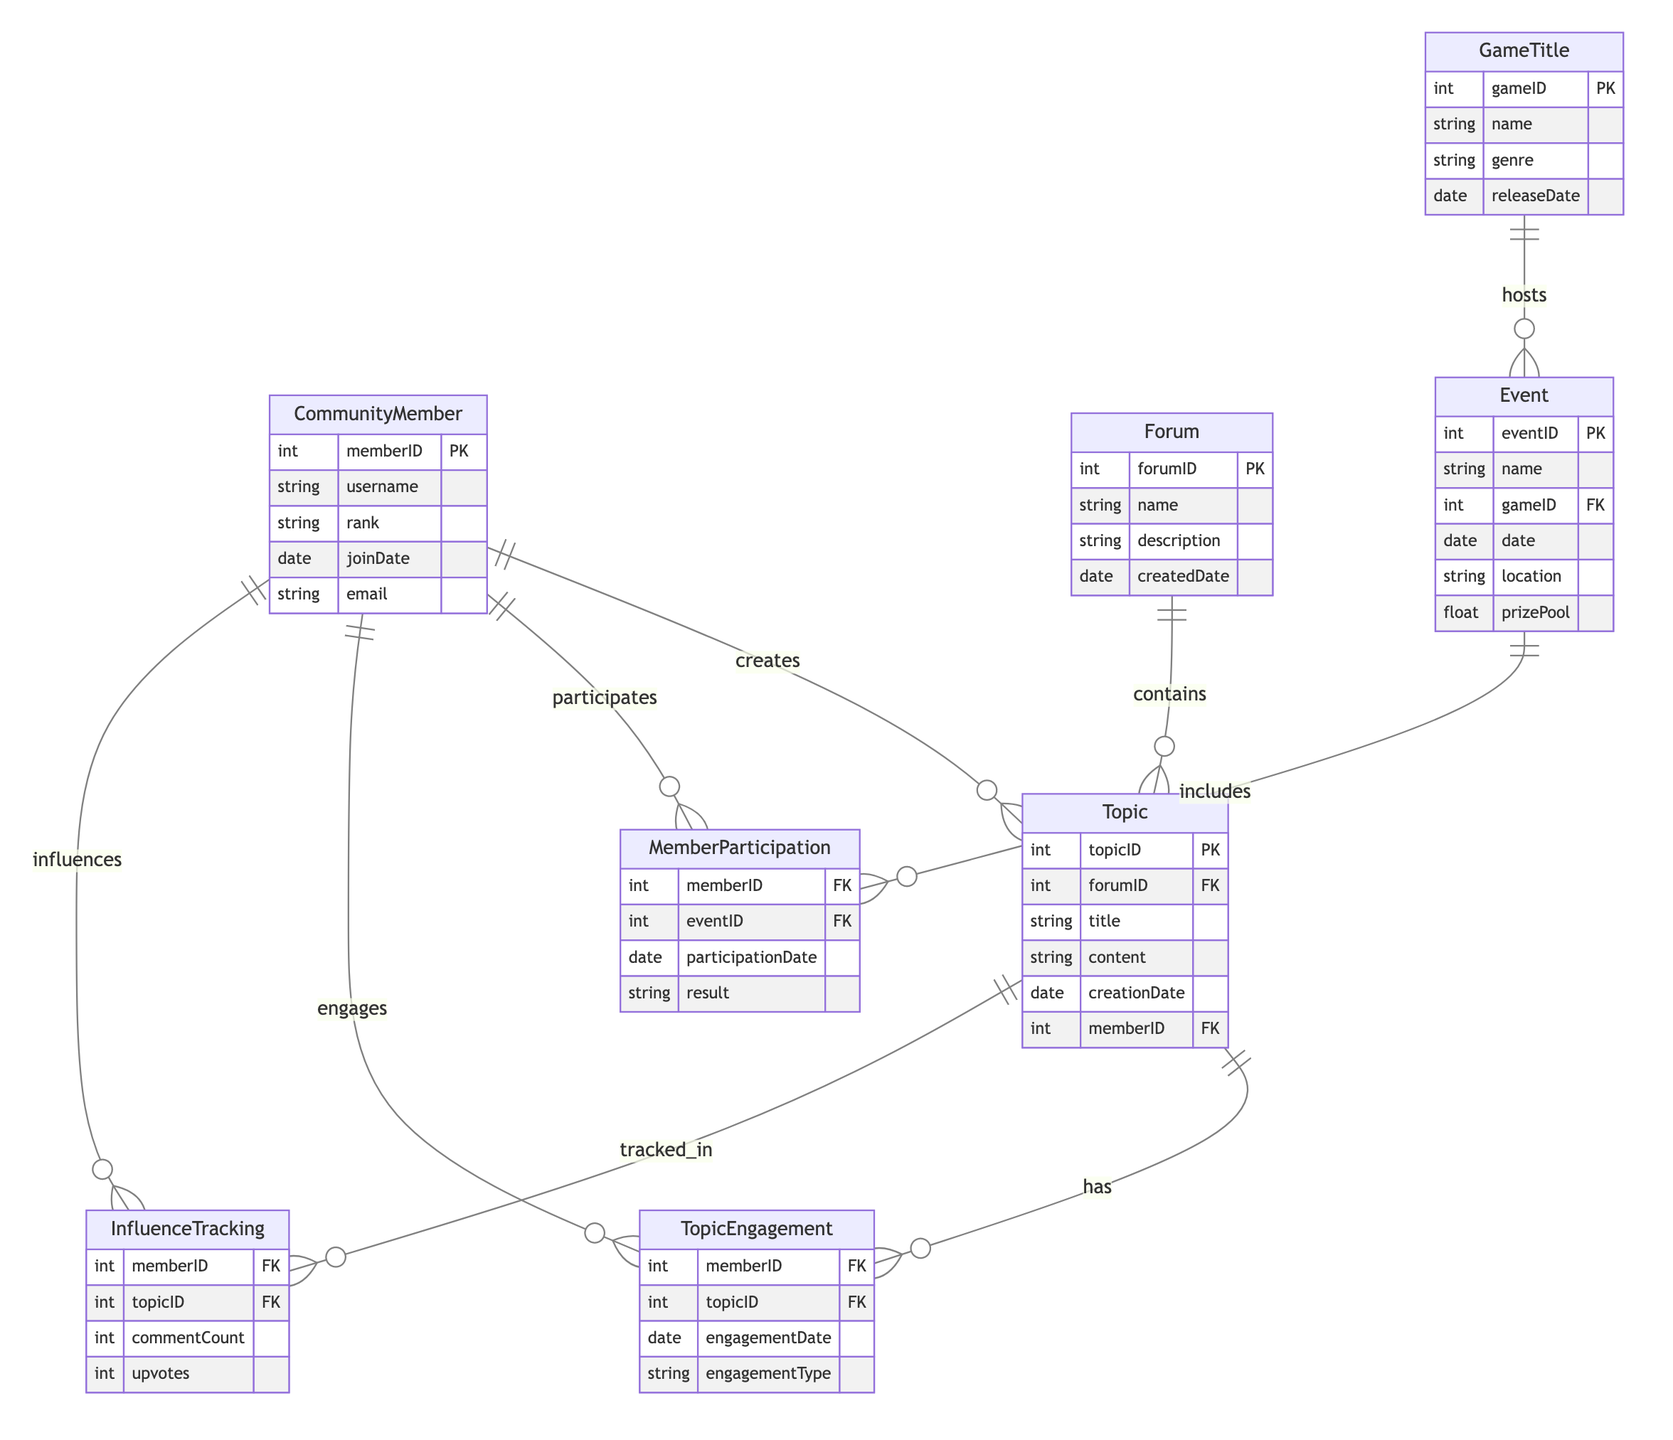What is the primary key of the CommunityMember entity? The primary key of the CommunityMember entity is memberID, which uniquely identifies each community member in the diagram.
Answer: memberID How many attributes does the GameTitle entity have? By inspecting the GameTitle entity in the diagram, it is clear that there are four attributes: gameID, name, genre, and releaseDate.
Answer: four What type of relationship exists between CommunityMember and Event? The relationship between CommunityMember and Event is many-to-many, indicating that multiple community members can participate in various events and vice versa.
Answer: many-to-many What is the foreign key in the Topic entity? In the Topic entity, the foreign key is forumID, which establishes a relationship to the Forum entity and identifies which forum the topic belongs to.
Answer: forumID Which entity contains the relationship that tracks the number of upvotes? The InfluenceTracking relationship tracks the number of upvotes associated with community members and topics, indicating the level of engagement or influence a member has on a topic.
Answer: InfluenceTracking How many events can a single community member participate in based on the diagram? Since the relationship between CommunityMember and Event is many-to-many, a single community member can participate in multiple events without a defined limit in the diagram.
Answer: multiple Which entity describes the prize pool for events? The Event entity contains the attribute prizePool, which describes the prizes available for a specific event within the gaming community.
Answer: Event What does the TopicEngagement relationship measure? The TopicEngagement relationship measures community members' interactions with topics, specifically through attributes like engagementDate and engagementType, highlighting how members engage with forum topics.
Answer: interactions What type of information is tracked in the InfluenceTracking relationship? The InfluenceTracking relationship tracks information regarding commentCount and upvotes, which indicates the impact a community member has on a topic in terms of engagement.
Answer: commentCount and upvotes 